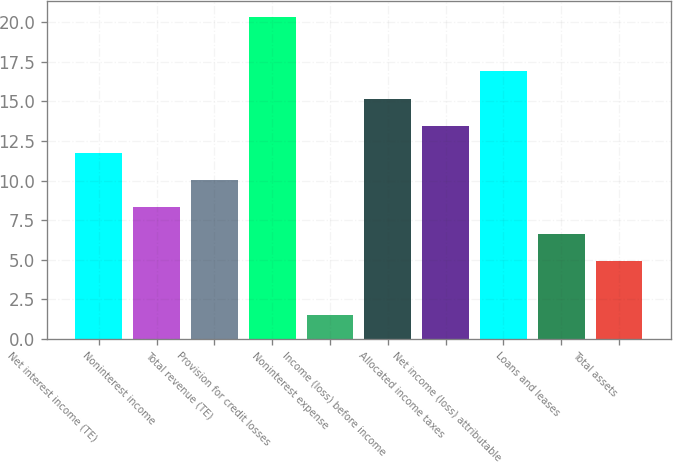Convert chart to OTSL. <chart><loc_0><loc_0><loc_500><loc_500><bar_chart><fcel>Net interest income (TE)<fcel>Noninterest income<fcel>Total revenue (TE)<fcel>Provision for credit losses<fcel>Noninterest expense<fcel>Income (loss) before income<fcel>Allocated income taxes<fcel>Net income (loss) attributable<fcel>Loans and leases<fcel>Total assets<nl><fcel>11.76<fcel>8.34<fcel>10.05<fcel>20.31<fcel>1.5<fcel>15.18<fcel>13.47<fcel>16.89<fcel>6.63<fcel>4.92<nl></chart> 